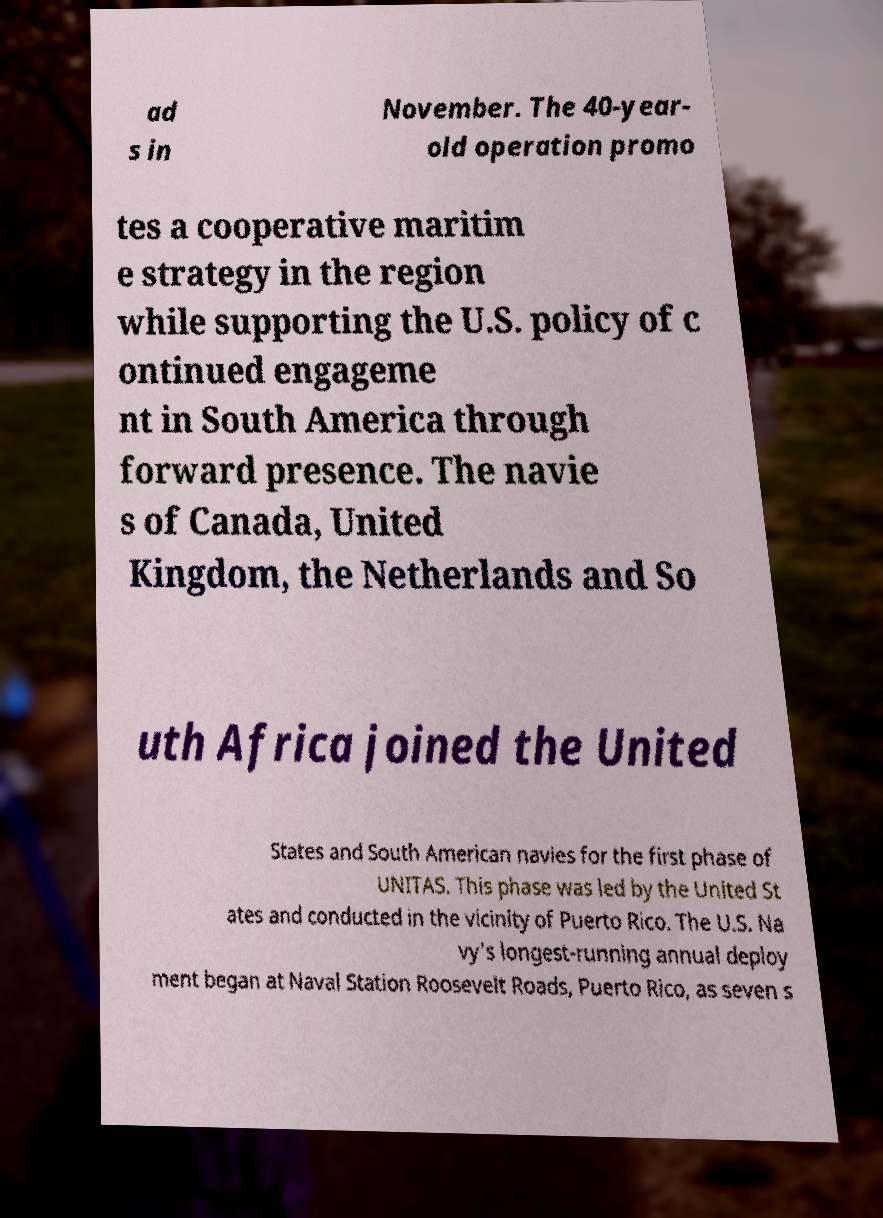For documentation purposes, I need the text within this image transcribed. Could you provide that? ad s in November. The 40-year- old operation promo tes a cooperative maritim e strategy in the region while supporting the U.S. policy of c ontinued engageme nt in South America through forward presence. The navie s of Canada, United Kingdom, the Netherlands and So uth Africa joined the United States and South American navies for the first phase of UNITAS. This phase was led by the United St ates and conducted in the vicinity of Puerto Rico. The U.S. Na vy's longest-running annual deploy ment began at Naval Station Roosevelt Roads, Puerto Rico, as seven s 